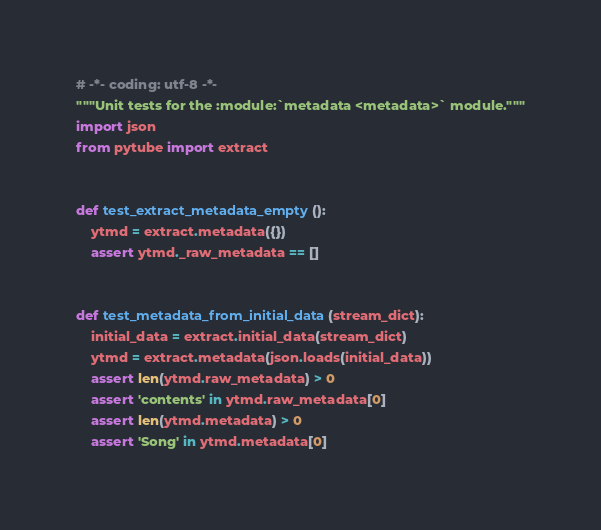<code> <loc_0><loc_0><loc_500><loc_500><_Python_># -*- coding: utf-8 -*-
"""Unit tests for the :module:`metadata <metadata>` module."""
import json
from pytube import extract


def test_extract_metadata_empty():
    ytmd = extract.metadata({})
    assert ytmd._raw_metadata == []


def test_metadata_from_initial_data(stream_dict):
    initial_data = extract.initial_data(stream_dict)
    ytmd = extract.metadata(json.loads(initial_data))
    assert len(ytmd.raw_metadata) > 0
    assert 'contents' in ytmd.raw_metadata[0]
    assert len(ytmd.metadata) > 0
    assert 'Song' in ytmd.metadata[0]
</code> 